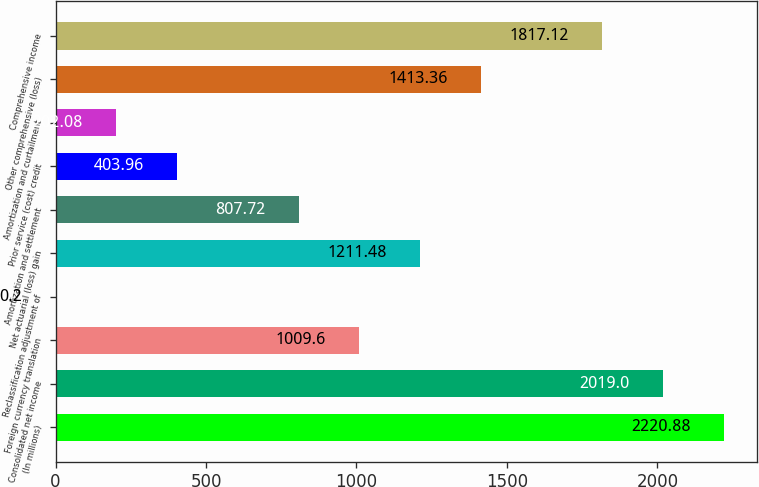Convert chart to OTSL. <chart><loc_0><loc_0><loc_500><loc_500><bar_chart><fcel>(In millions)<fcel>Consolidated net income<fcel>Foreign currency translation<fcel>Reclassification adjustment of<fcel>Net actuarial (loss) gain<fcel>Amortization and settlement<fcel>Prior service (cost) credit<fcel>Amortization and curtailment<fcel>Other comprehensive (loss)<fcel>Comprehensive income<nl><fcel>2220.88<fcel>2019<fcel>1009.6<fcel>0.2<fcel>1211.48<fcel>807.72<fcel>403.96<fcel>202.08<fcel>1413.36<fcel>1817.12<nl></chart> 